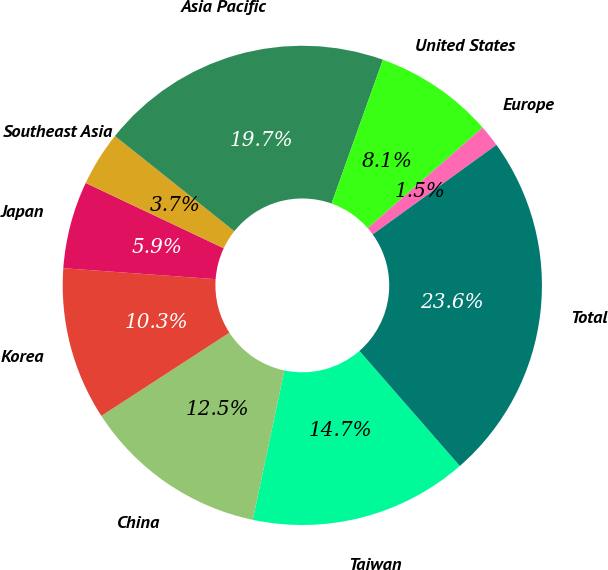Convert chart to OTSL. <chart><loc_0><loc_0><loc_500><loc_500><pie_chart><fcel>Taiwan<fcel>China<fcel>Korea<fcel>Japan<fcel>Southeast Asia<fcel>Asia Pacific<fcel>United States<fcel>Europe<fcel>Total<nl><fcel>14.73%<fcel>12.52%<fcel>10.31%<fcel>5.89%<fcel>3.68%<fcel>19.75%<fcel>8.1%<fcel>1.47%<fcel>23.56%<nl></chart> 